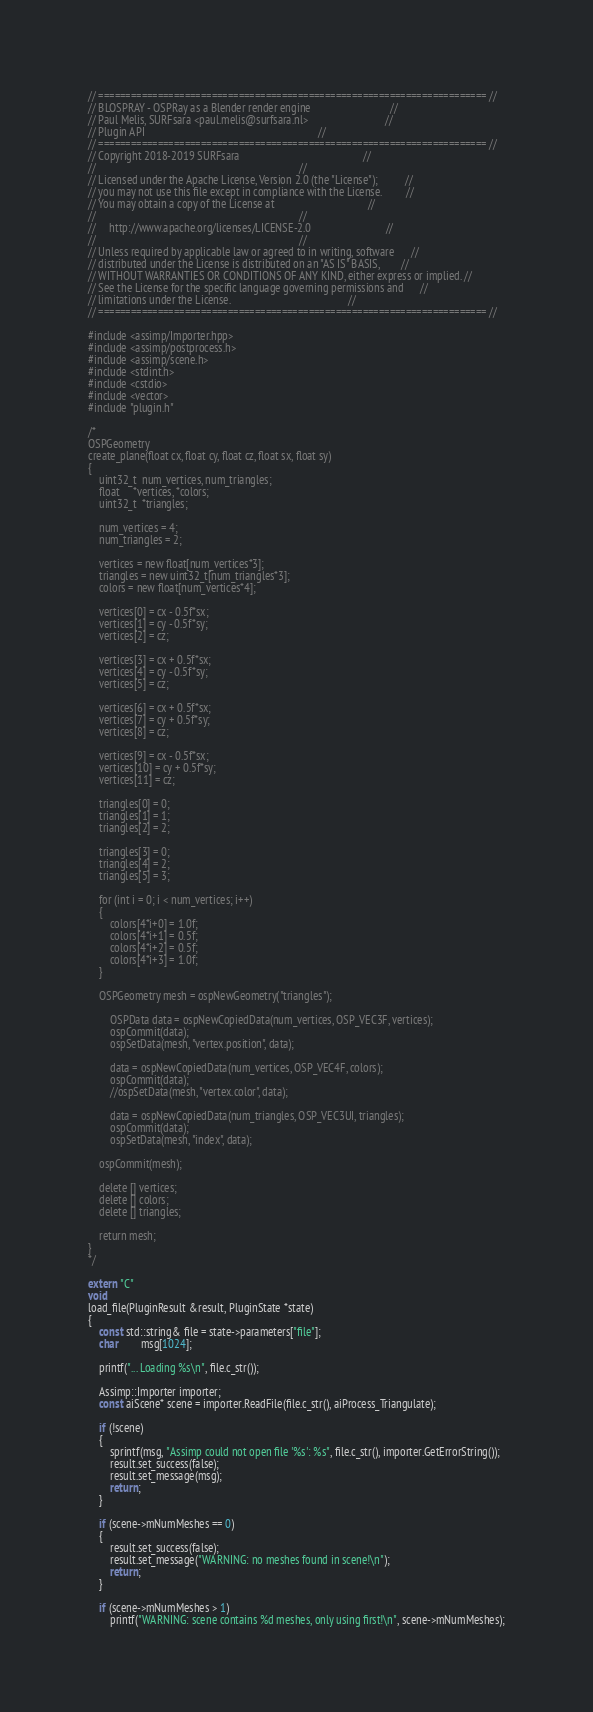<code> <loc_0><loc_0><loc_500><loc_500><_C++_>// ======================================================================== //
// BLOSPRAY - OSPRay as a Blender render engine                             //
// Paul Melis, SURFsara <paul.melis@surfsara.nl>                            //
// Plugin API                                                               //
// ======================================================================== //
// Copyright 2018-2019 SURFsara                                             //
//                                                                          //
// Licensed under the Apache License, Version 2.0 (the "License");          //
// you may not use this file except in compliance with the License.         //
// You may obtain a copy of the License at                                  //
//                                                                          //
//     http://www.apache.org/licenses/LICENSE-2.0                           //
//                                                                          //
// Unless required by applicable law or agreed to in writing, software      //
// distributed under the License is distributed on an "AS IS" BASIS,        //
// WITHOUT WARRANTIES OR CONDITIONS OF ANY KIND, either express or implied. //
// See the License for the specific language governing permissions and      //
// limitations under the License.                                           //
// ======================================================================== //

#include <assimp/Importer.hpp>
#include <assimp/postprocess.h> 
#include <assimp/scene.h> 
#include <stdint.h>
#include <cstdio>
#include <vector>
#include "plugin.h"

/*
OSPGeometry
create_plane(float cx, float cy, float cz, float sx, float sy)
{
    uint32_t  num_vertices, num_triangles;
    float     *vertices, *colors;  
    uint32_t  *triangles;    
    
    num_vertices = 4;
    num_triangles = 2;
    
    vertices = new float[num_vertices*3];
    triangles = new uint32_t[num_triangles*3];
    colors = new float[num_vertices*4];
    
    vertices[0] = cx - 0.5f*sx;
    vertices[1] = cy - 0.5f*sy;
    vertices[2] = cz;

    vertices[3] = cx + 0.5f*sx;
    vertices[4] = cy - 0.5f*sy;
    vertices[5] = cz;

    vertices[6] = cx + 0.5f*sx;
    vertices[7] = cy + 0.5f*sy;
    vertices[8] = cz;

    vertices[9] = cx - 0.5f*sx;
    vertices[10] = cy + 0.5f*sy;
    vertices[11] = cz;
    
    triangles[0] = 0;
    triangles[1] = 1;
    triangles[2] = 2;

    triangles[3] = 0;
    triangles[4] = 2;
    triangles[5] = 3;

    for (int i = 0; i < num_vertices; i++)
    {
        colors[4*i+0] = 1.0f;
        colors[4*i+1] = 0.5f;
        colors[4*i+2] = 0.5f;
        colors[4*i+3] = 1.0f;
    }    
    
    OSPGeometry mesh = ospNewGeometry("triangles");
  
        OSPData data = ospNewCopiedData(num_vertices, OSP_VEC3F, vertices);   
        ospCommit(data);
        ospSetData(mesh, "vertex.position", data);

        data = ospNewCopiedData(num_vertices, OSP_VEC4F, colors);
        ospCommit(data);
        //ospSetData(mesh, "vertex.color", data);

        data = ospNewCopiedData(num_triangles, OSP_VEC3UI, triangles);            
        ospCommit(data);
        ospSetData(mesh, "index", data);

    ospCommit(mesh);
    
    delete [] vertices;
    delete [] colors;
    delete [] triangles;    
    
    return mesh;
}
*/

extern "C"
void
load_file(PluginResult &result, PluginState *state)
{
    const std::string& file = state->parameters["file"];
    char        msg[1024];

    printf("... Loading %s\n", file.c_str());

    Assimp::Importer importer;
    const aiScene* scene = importer.ReadFile(file.c_str(), aiProcess_Triangulate);

    if (!scene)
    {
        sprintf(msg, "Assimp could not open file '%s': %s", file.c_str(), importer.GetErrorString());
        result.set_success(false);
        result.set_message(msg);
        return;
    }

    if (scene->mNumMeshes == 0)
    {
        result.set_success(false);
        result.set_message("WARNING: no meshes found in scene!\n");
        return;
    }

    if (scene->mNumMeshes > 1)
        printf("WARNING: scene contains %d meshes, only using first!\n", scene->mNumMeshes);
</code> 